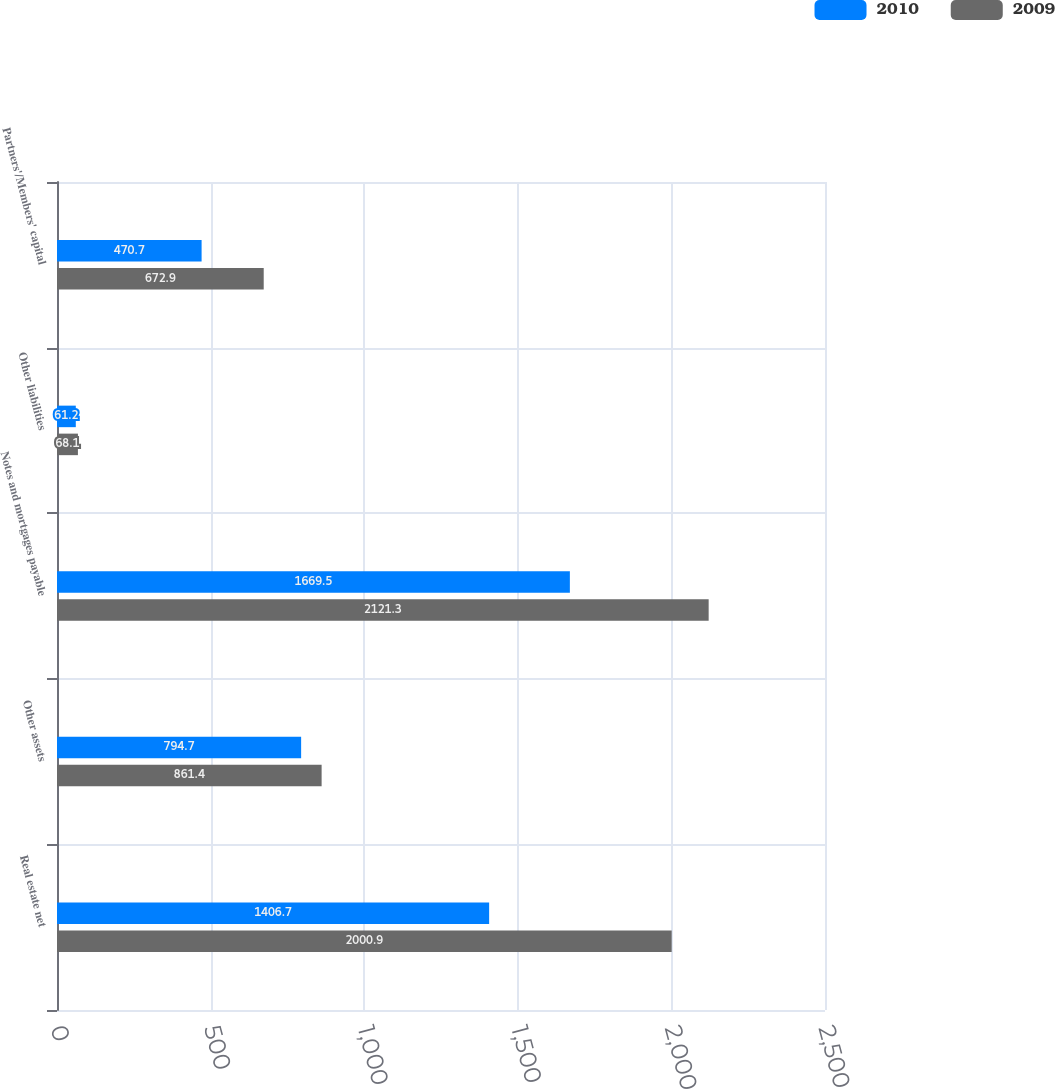<chart> <loc_0><loc_0><loc_500><loc_500><stacked_bar_chart><ecel><fcel>Real estate net<fcel>Other assets<fcel>Notes and mortgages payable<fcel>Other liabilities<fcel>Partners'/Members' capital<nl><fcel>2010<fcel>1406.7<fcel>794.7<fcel>1669.5<fcel>61.2<fcel>470.7<nl><fcel>2009<fcel>2000.9<fcel>861.4<fcel>2121.3<fcel>68.1<fcel>672.9<nl></chart> 